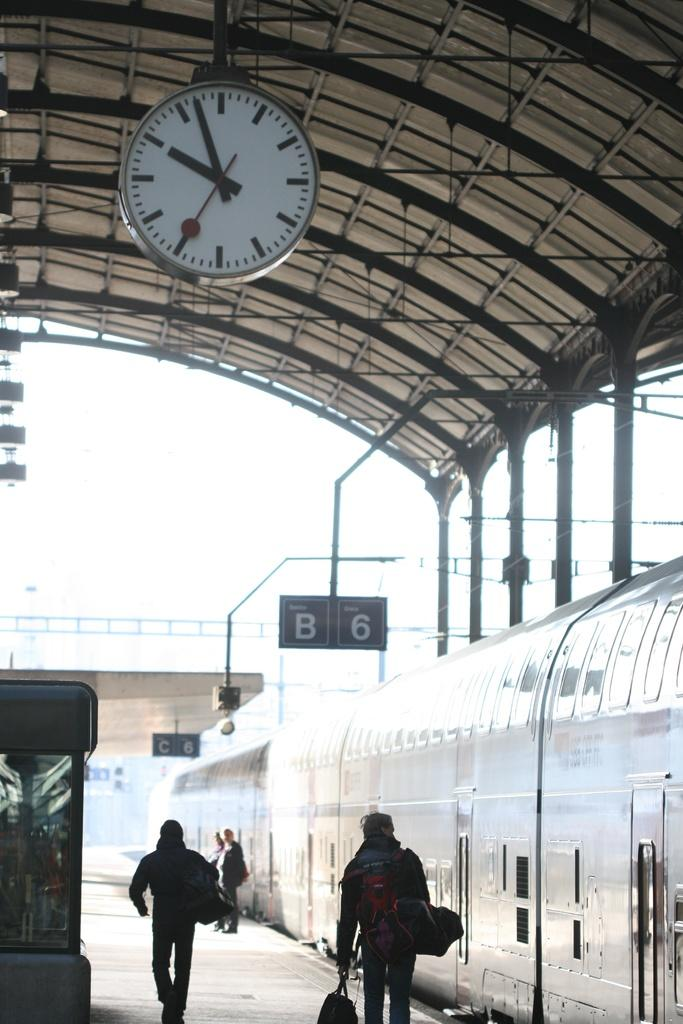<image>
Provide a brief description of the given image. The letter B can be seen hanging from above with people walking under alongside the train. 